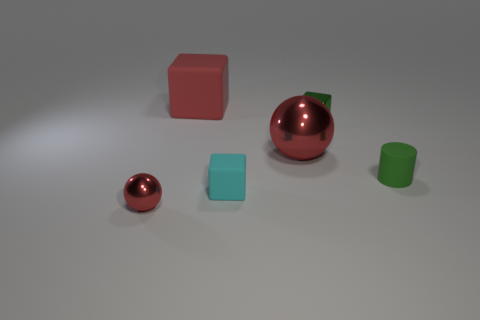Subtract all tiny blocks. How many blocks are left? 1 Add 2 green matte objects. How many objects exist? 8 Subtract all cyan cubes. How many cubes are left? 2 Subtract 1 balls. How many balls are left? 1 Subtract all balls. How many objects are left? 4 Subtract all cyan spheres. Subtract all cyan blocks. How many spheres are left? 2 Subtract all yellow cylinders. How many green blocks are left? 1 Subtract all tiny cyan matte things. Subtract all large cubes. How many objects are left? 4 Add 6 green shiny objects. How many green shiny objects are left? 7 Add 2 tiny green metallic things. How many tiny green metallic things exist? 3 